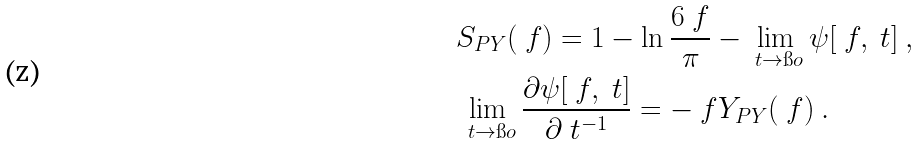Convert formula to latex. <formula><loc_0><loc_0><loc_500><loc_500>& S _ { P Y } ( \ f ) = 1 - \ln \frac { 6 \ f } { \pi } - \lim _ { \ t \to \i o } \psi [ \ f , \ t ] \ , \\ & \lim _ { \ t \to \i o } \frac { \partial \psi [ \ f , \ t ] } { \partial \ t ^ { - 1 } } = - \ f Y _ { P Y } ( \ f ) \ .</formula> 